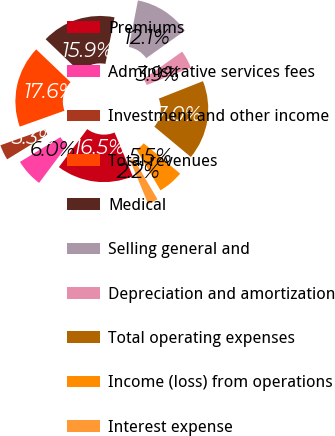<chart> <loc_0><loc_0><loc_500><loc_500><pie_chart><fcel>Premiums<fcel>Administrative services fees<fcel>Investment and other income<fcel>Total revenues<fcel>Medical<fcel>Selling general and<fcel>Depreciation and amortization<fcel>Total operating expenses<fcel>Income (loss) from operations<fcel>Interest expense<nl><fcel>16.48%<fcel>6.04%<fcel>3.3%<fcel>17.58%<fcel>15.93%<fcel>12.09%<fcel>3.85%<fcel>17.03%<fcel>5.49%<fcel>2.2%<nl></chart> 